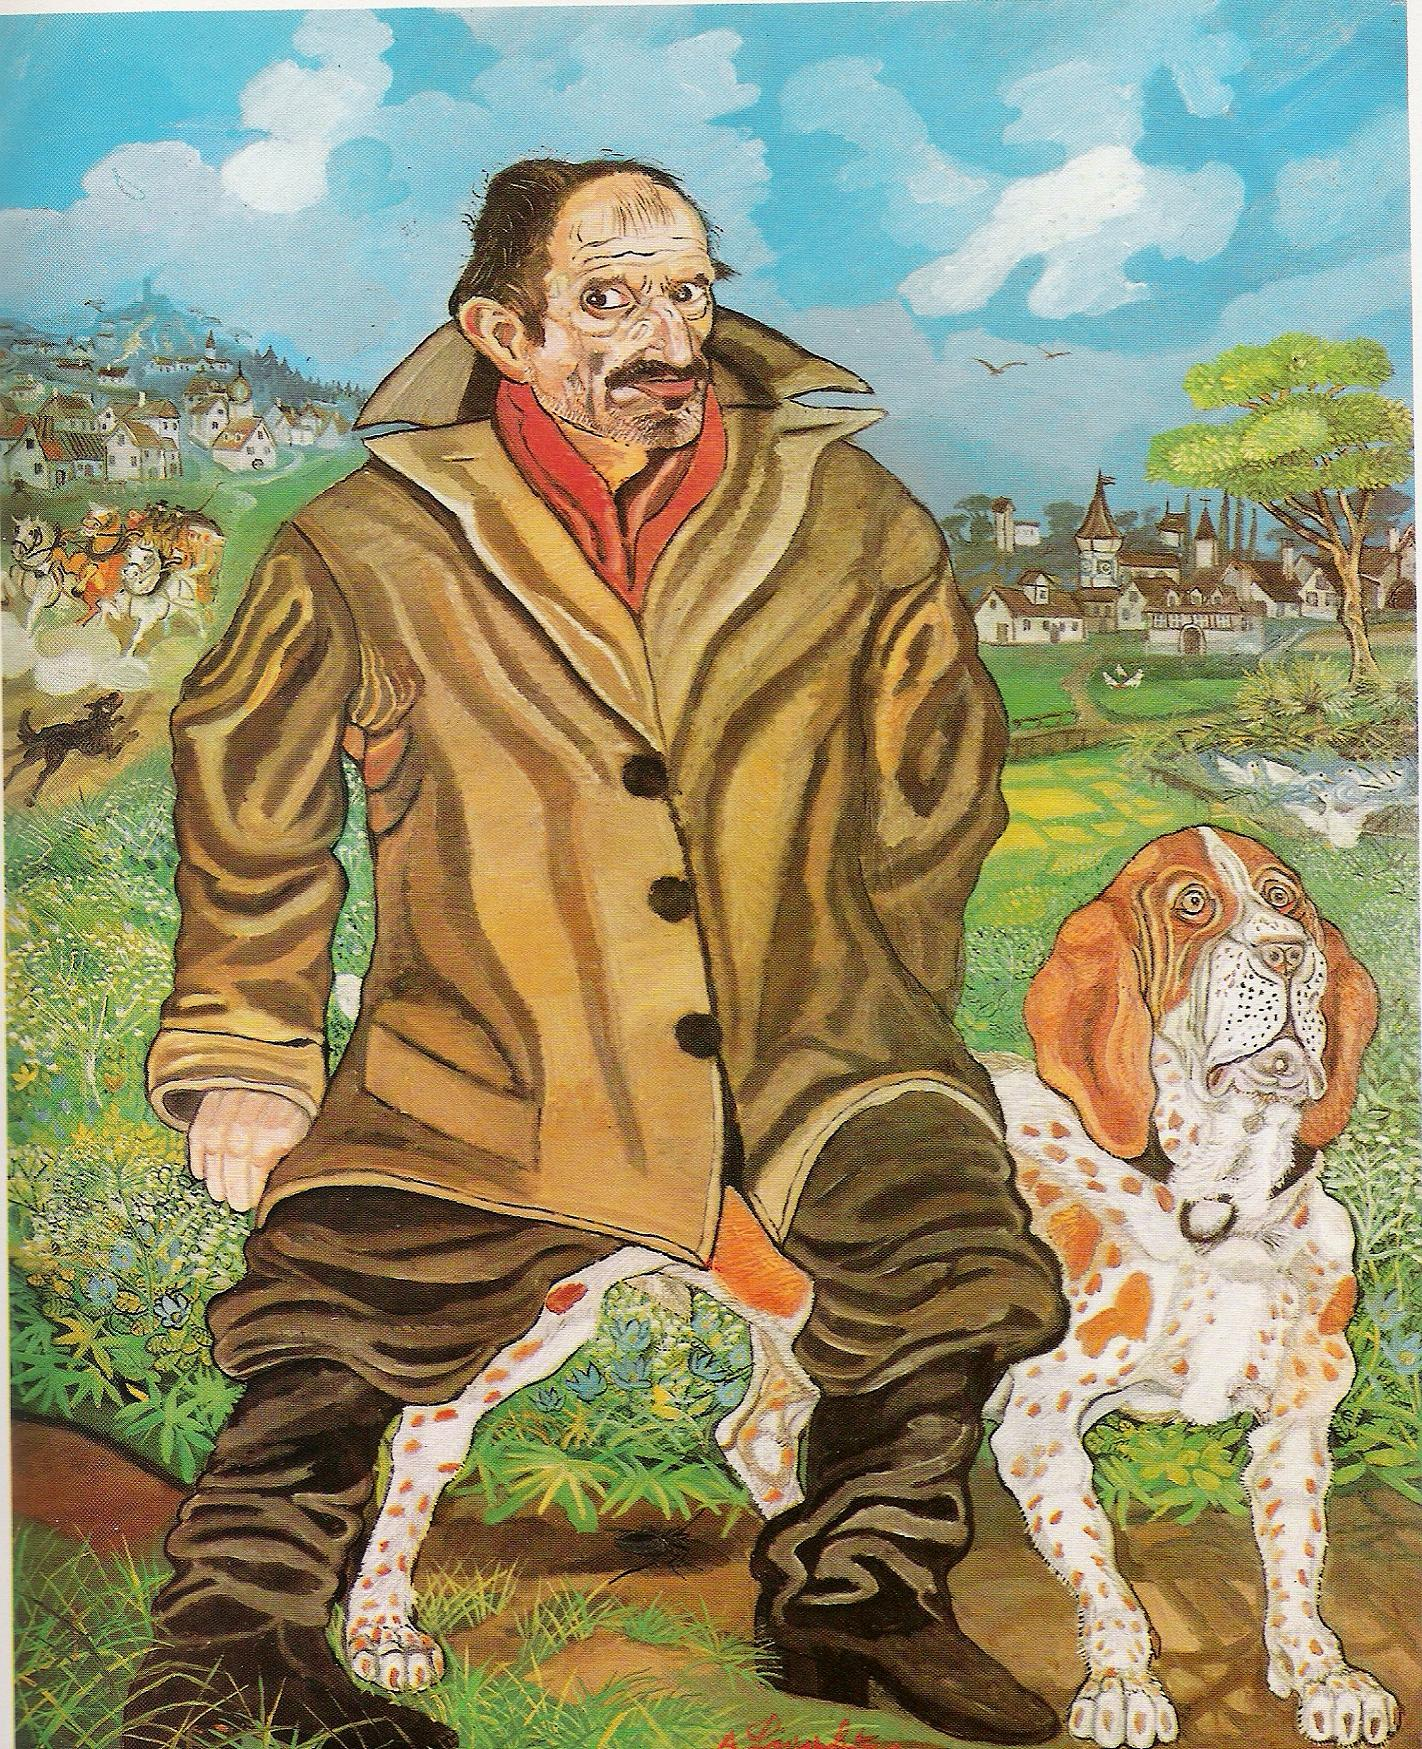Can you elaborate on the elements of the picture provided? The image features an intriguing scene where a man and his dog are set against a fantastical backdrop. The man has a pronounced large nose and a distinct mustache, wearing a substantial brown coat and a red scarf which gives him a distinctive appearance. Beside him is his loyal companion, a dog with white fur and brown spots and notably floppy ears. The environment around them is incredibly vibrant and colorful, looking like something out of a fairy tale or dream. You can see a detailed village, a majestic castle in the distance, and a serene river flowing through the landscape. The artistic style is distinctly surreal, combining unexpected elements in a harmony that evokes a sense of wonder and imaginative exploration. The use of bright and contrasting colors contributes to the dreamy and whimsical atmosphere of the artwork. 